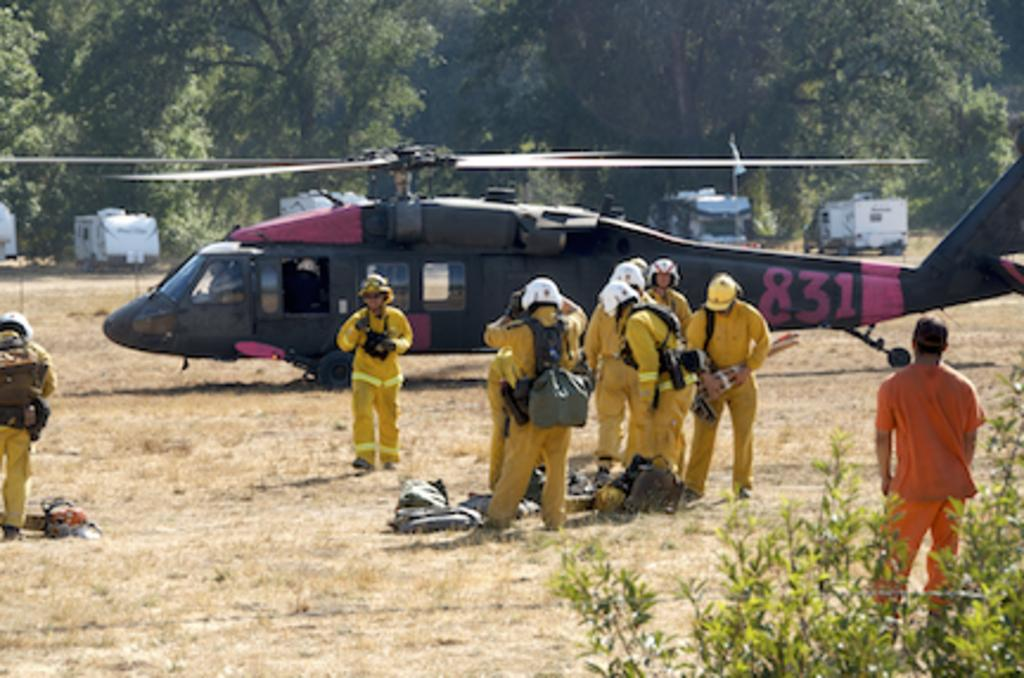<image>
Provide a brief description of the given image. a helicopter that has 831 on the side 